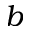Convert formula to latex. <formula><loc_0><loc_0><loc_500><loc_500>b</formula> 